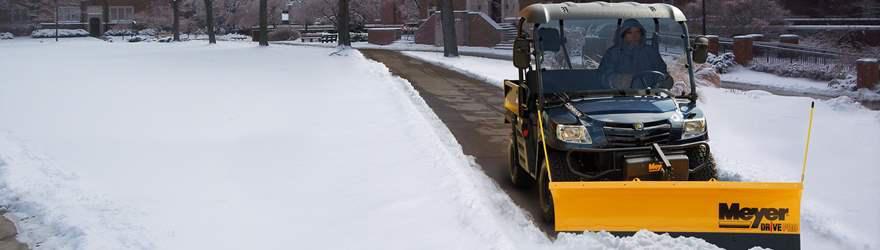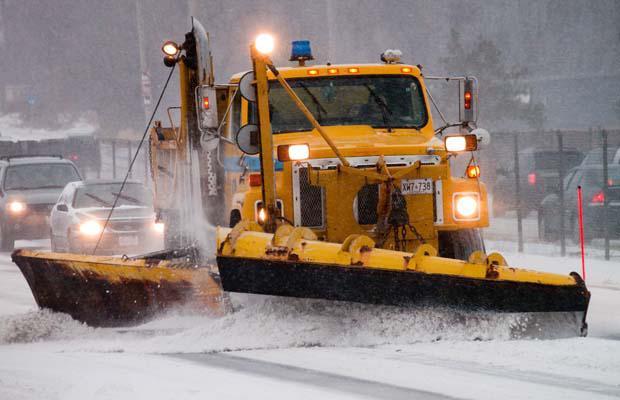The first image is the image on the left, the second image is the image on the right. For the images shown, is this caption "A pickup truck with a yellow bulldozer front attachment is pushing a pile of snow." true? Answer yes or no. No. The first image is the image on the left, the second image is the image on the right. Assess this claim about the two images: "All images include a vehicle pushing a bright yellow plow through snow, and one image features a truck with a bright yellow cab.". Correct or not? Answer yes or no. Yes. 